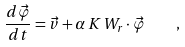Convert formula to latex. <formula><loc_0><loc_0><loc_500><loc_500>\frac { d { \vec { \varphi } } } { d t } = { \vec { v } } + \alpha \, K \, { W } _ { r } \cdot { \vec { \varphi } } \quad ,</formula> 